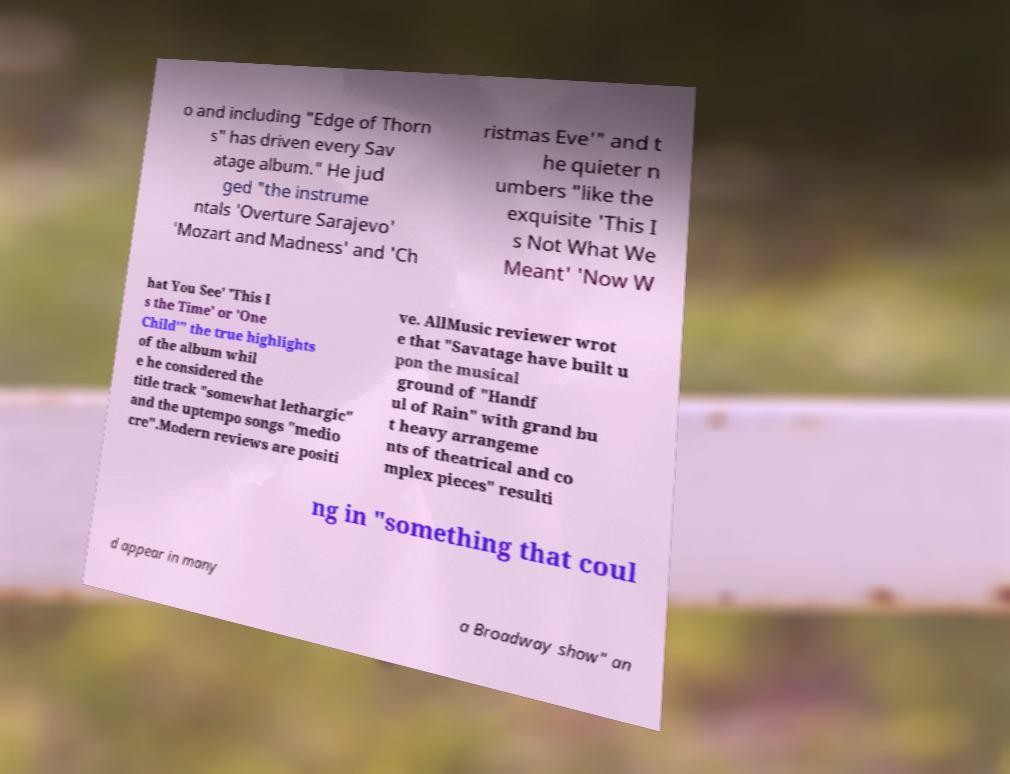Could you extract and type out the text from this image? o and including "Edge of Thorn s" has driven every Sav atage album." He jud ged "the instrume ntals 'Overture Sarajevo' 'Mozart and Madness' and 'Ch ristmas Eve'" and t he quieter n umbers "like the exquisite 'This I s Not What We Meant' 'Now W hat You See' 'This I s the Time' or 'One Child'" the true highlights of the album whil e he considered the title track "somewhat lethargic" and the uptempo songs "medio cre".Modern reviews are positi ve. AllMusic reviewer wrot e that "Savatage have built u pon the musical ground of "Handf ul of Rain" with grand bu t heavy arrangeme nts of theatrical and co mplex pieces" resulti ng in "something that coul d appear in many a Broadway show" an 